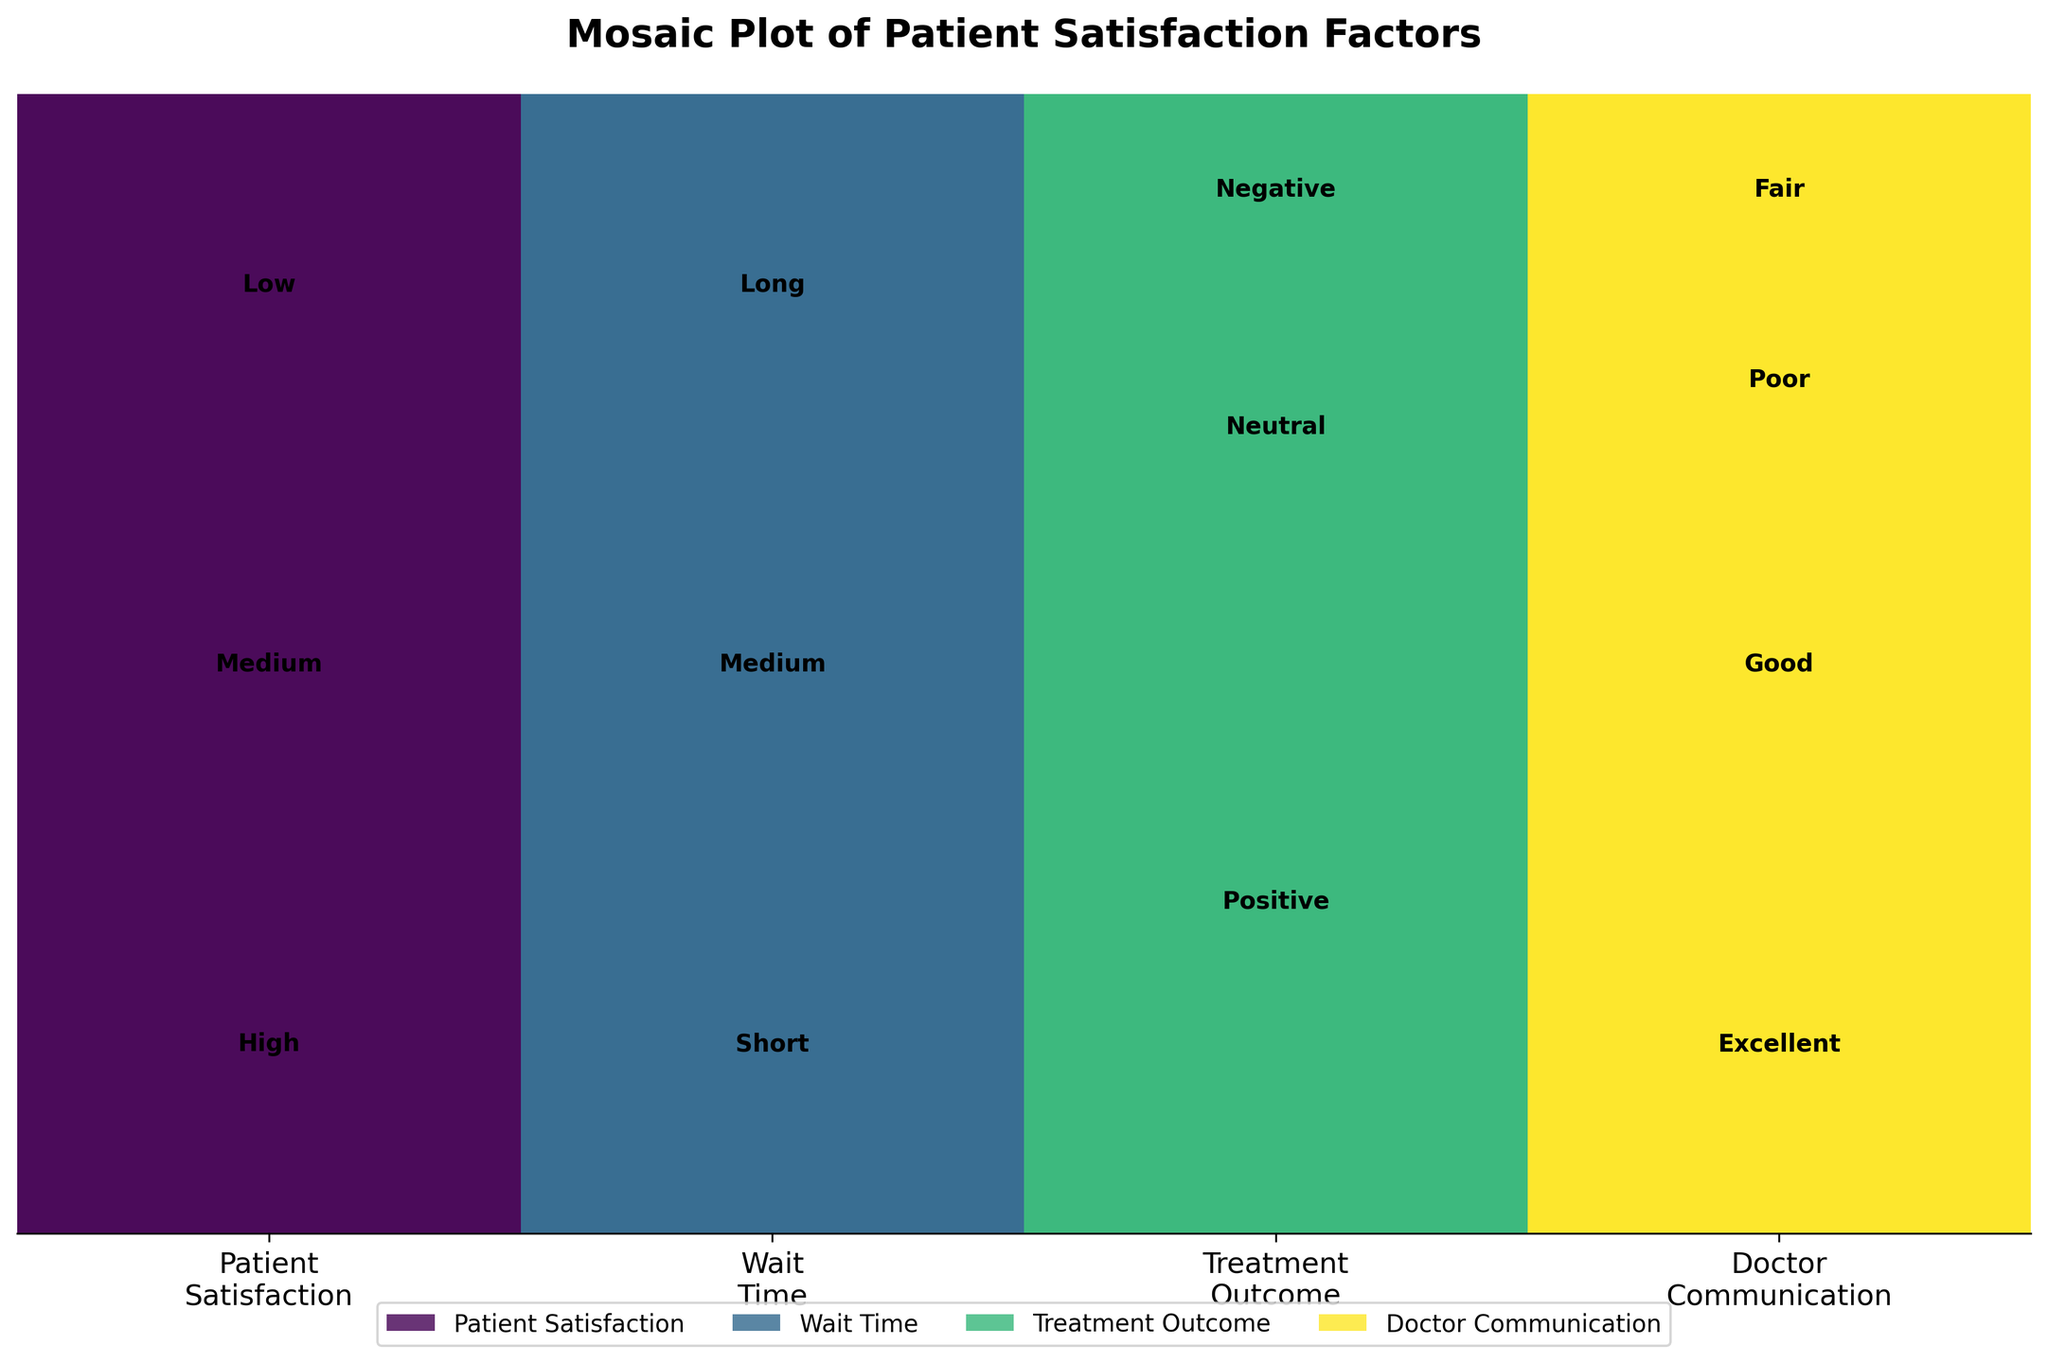what is the dominant category in patient satisfaction? To find the dominant category, observe the heights of the bars representing patient satisfaction levels. The "High" category has the largest height, indicating it is the dominant category.
Answer: High what colors represent each patient satisfaction factor? Refer to the colors used in the plot and their corresponding labels in the legend. The colors are: Patient Satisfaction in green, Wait Time in blue, Treatment Outcome in purple, and Doctor Communication in yellow.
Answer: green, blue, purple, yellow which wait time category has the least patient satisfaction counts? Look at the section under "Wait Time" and identify the category with the smallest bar. The "Long" category has the smallest representation.
Answer: Long how does the count of 'excellent' doctor communication compare to 'poor'? Compare the heights of the bars under the "Doctor Communication" category for "Excellent" and "Poor". The bar for "Excellent" is taller compared to "Poor".
Answer: Excellent is higher what is the total number of entries for 'treatment outcome'? Sum the counts for all levels under the "Treatment Outcome" category. All categories - Positive, Neutral, and Negative add up to give the total.
Answer: 12 are there more 'short' wait times or 'medium' wait times? Observe the bar heights under the "Wait Time" category and compare the "Short" and "Medium" bars. The "Short" bar is higher than the "Medium" bar.
Answer: Short which treatment outcome has the most counts and how do you know? Check the heights of the bars under "Treatment Outcome". The "Positive" outcome bar is the tallest, indicating it has the most counts.
Answer: Positive what percentage of the 'medium' wait times result in 'high' patient satisfaction? Analyze the "Medium" wait time segment under "Wait Time" and check for the portion that overlaps with "High" patient satisfaction. Since the exact values are visual estimates, we observe that "Medium" wait times contribute less to "High" patient satisfaction.
Answer: Less than 50% which factor appears to have the most influence on 'high' patient satisfaction? Consider which factor's segment for "High" patient satisfaction is most prominent. "Doctor Communication" with "Excellent" rating appears as the most influential due to larger representation in "High" satisfaction.
Answer: Doctor Communication 